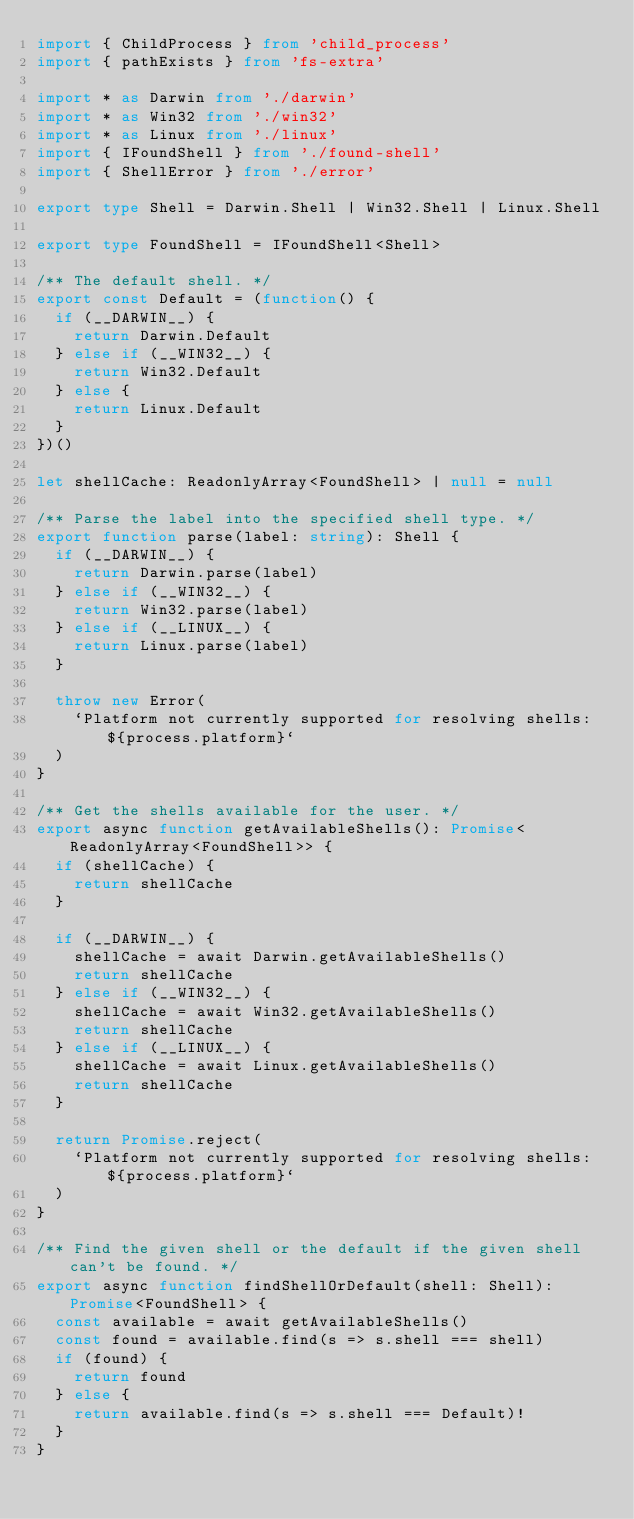<code> <loc_0><loc_0><loc_500><loc_500><_TypeScript_>import { ChildProcess } from 'child_process'
import { pathExists } from 'fs-extra'

import * as Darwin from './darwin'
import * as Win32 from './win32'
import * as Linux from './linux'
import { IFoundShell } from './found-shell'
import { ShellError } from './error'

export type Shell = Darwin.Shell | Win32.Shell | Linux.Shell

export type FoundShell = IFoundShell<Shell>

/** The default shell. */
export const Default = (function() {
  if (__DARWIN__) {
    return Darwin.Default
  } else if (__WIN32__) {
    return Win32.Default
  } else {
    return Linux.Default
  }
})()

let shellCache: ReadonlyArray<FoundShell> | null = null

/** Parse the label into the specified shell type. */
export function parse(label: string): Shell {
  if (__DARWIN__) {
    return Darwin.parse(label)
  } else if (__WIN32__) {
    return Win32.parse(label)
  } else if (__LINUX__) {
    return Linux.parse(label)
  }

  throw new Error(
    `Platform not currently supported for resolving shells: ${process.platform}`
  )
}

/** Get the shells available for the user. */
export async function getAvailableShells(): Promise<ReadonlyArray<FoundShell>> {
  if (shellCache) {
    return shellCache
  }

  if (__DARWIN__) {
    shellCache = await Darwin.getAvailableShells()
    return shellCache
  } else if (__WIN32__) {
    shellCache = await Win32.getAvailableShells()
    return shellCache
  } else if (__LINUX__) {
    shellCache = await Linux.getAvailableShells()
    return shellCache
  }

  return Promise.reject(
    `Platform not currently supported for resolving shells: ${process.platform}`
  )
}

/** Find the given shell or the default if the given shell can't be found. */
export async function findShellOrDefault(shell: Shell): Promise<FoundShell> {
  const available = await getAvailableShells()
  const found = available.find(s => s.shell === shell)
  if (found) {
    return found
  } else {
    return available.find(s => s.shell === Default)!
  }
}
</code> 